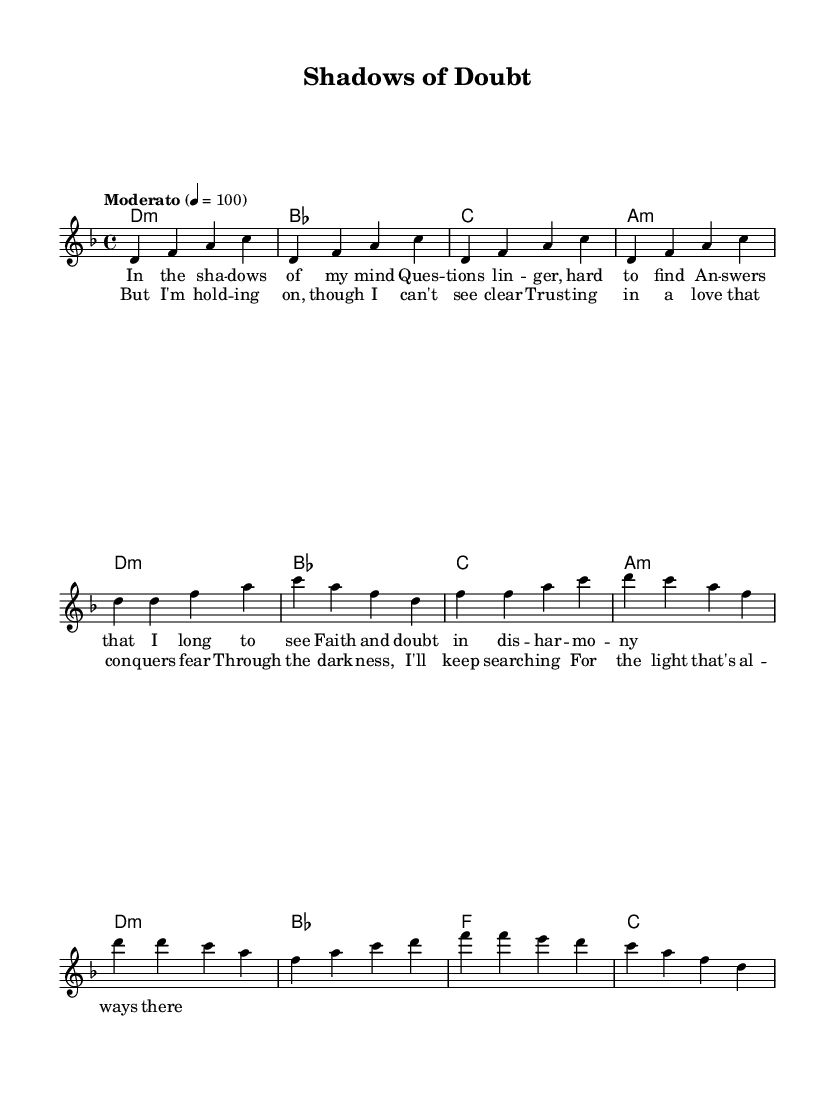What is the key signature of this music? The key signature is D minor, which is characterized by one flat (B♭) indicated at the beginning.
Answer: D minor What is the time signature of this music? The time signature is 4/4, which means there are four beats in each measure and the quarter note receives one beat.
Answer: 4/4 What is the tempo marking in this music? The tempo marking is "Moderato," indicating a moderate pace, and the metronome marking is 4 = 100, meaning 100 beats per minute.
Answer: Moderato How many measures are in the verse section of the music? The verse consists of four measures, which can be counted by observing the repeated pattern of notes and chords that fits within four distinct groupings.
Answer: 4 What is the emotional theme reflected in the lyrics of the chorus? The lyrics of the chorus express hope and perseverance despite doubt, as it emphasizes holding on to faith and searching for light.
Answer: Hope How does the harmony change in the chorus compared to the verse? In the chorus, the harmony progresses from D minor to B♭ and then to F, indicating a shift that introduces new chords that support the growth in lyrical emotion.
Answer: D minor to B flat to F What does the phrase "shadows of doubt" symbolize in contemporary Christian music? The phrase symbolizes the struggles of faith and uncertainty that individuals often face, resonating with themes of questioning and searching for belief in difficult times.
Answer: Struggles of faith 